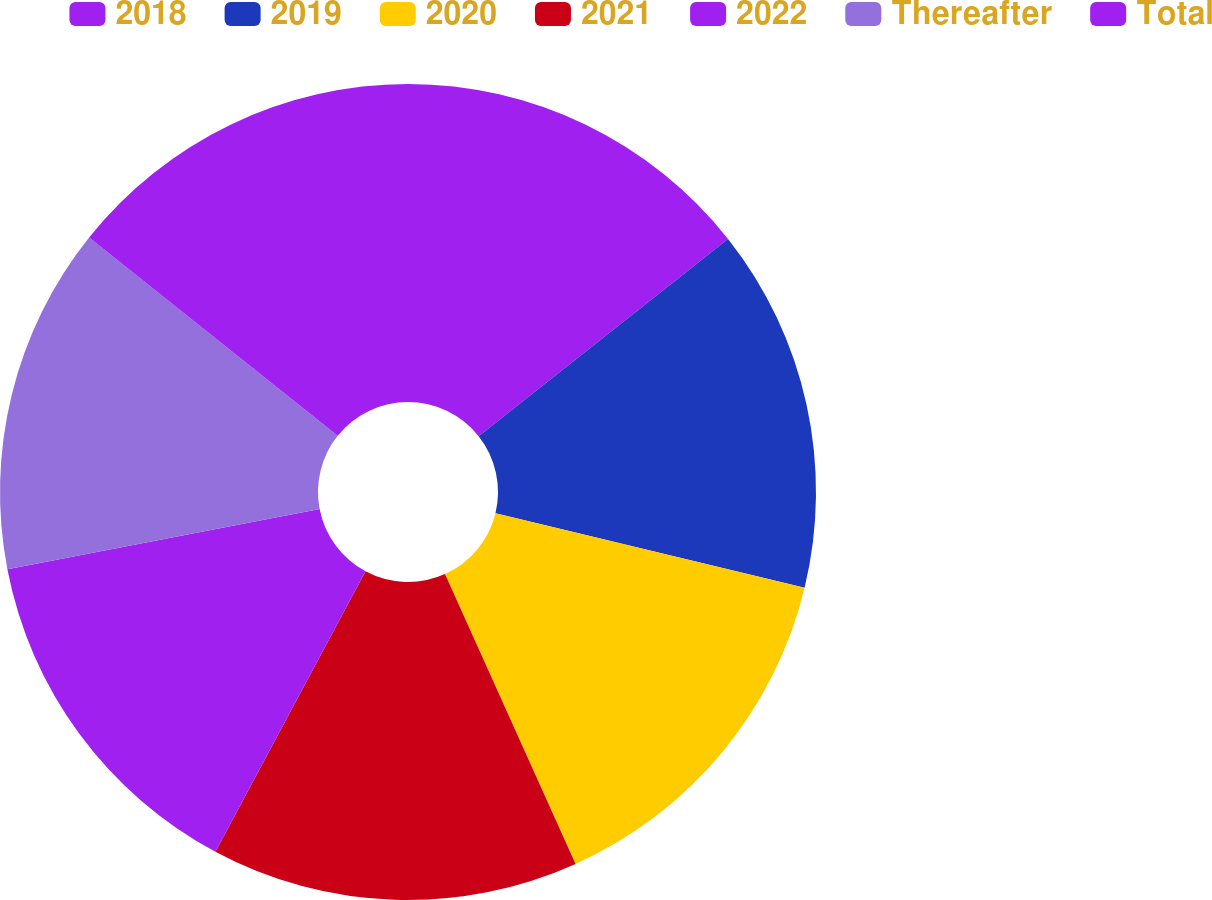<chart> <loc_0><loc_0><loc_500><loc_500><pie_chart><fcel>2018<fcel>2019<fcel>2020<fcel>2021<fcel>2022<fcel>Thereafter<fcel>Total<nl><fcel>14.35%<fcel>14.42%<fcel>14.49%<fcel>14.56%<fcel>14.14%<fcel>13.75%<fcel>14.28%<nl></chart> 